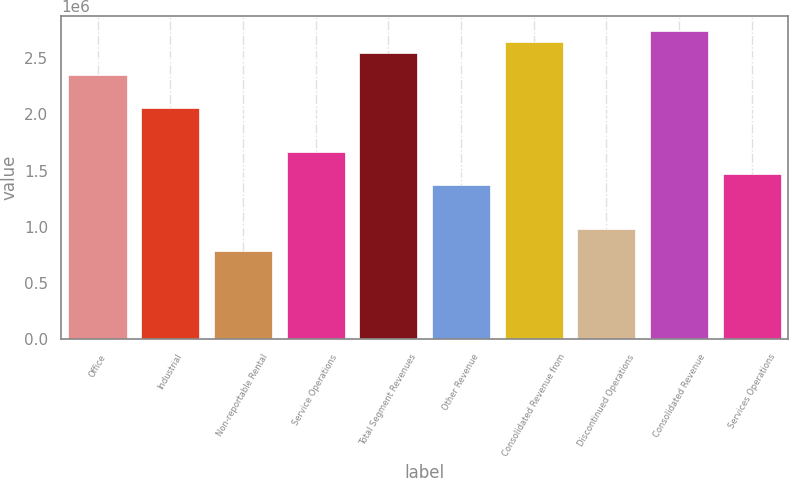Convert chart to OTSL. <chart><loc_0><loc_0><loc_500><loc_500><bar_chart><fcel>Office<fcel>Industrial<fcel>Non-reportable Rental<fcel>Service Operations<fcel>Total Segment Revenues<fcel>Other Revenue<fcel>Consolidated Revenue from<fcel>Discontinued Operations<fcel>Consolidated Revenue<fcel>Services Operations<nl><fcel>2.34852e+06<fcel>2.055e+06<fcel>783115<fcel>1.66365e+06<fcel>2.54419e+06<fcel>1.37014e+06<fcel>2.64203e+06<fcel>978790<fcel>2.73986e+06<fcel>1.46798e+06<nl></chart> 